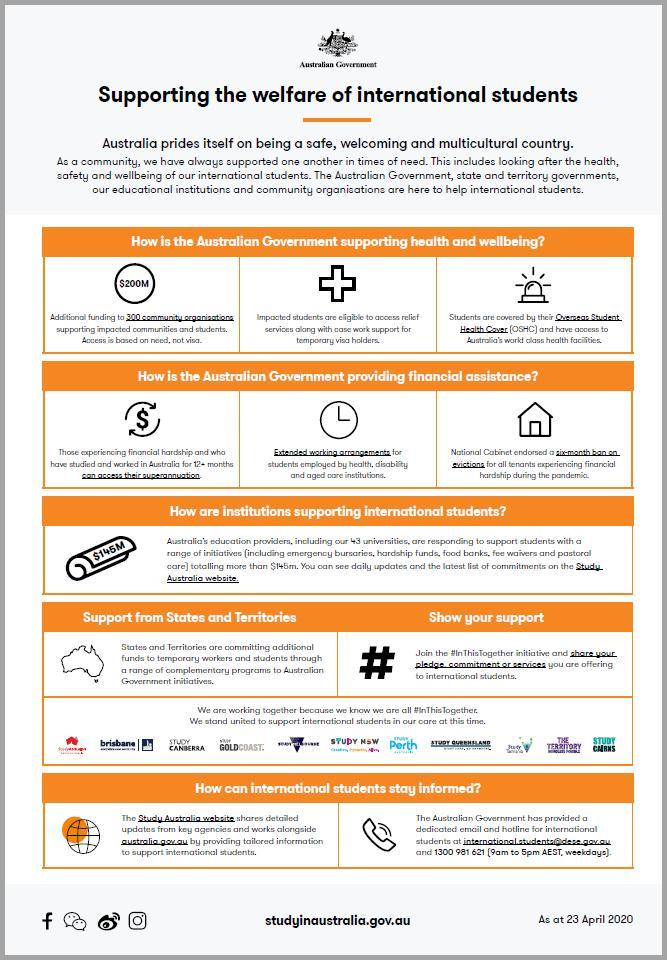How many points are under the heading "Supporting the welfare of international students"?
Answer the question with a short phrase. 5 